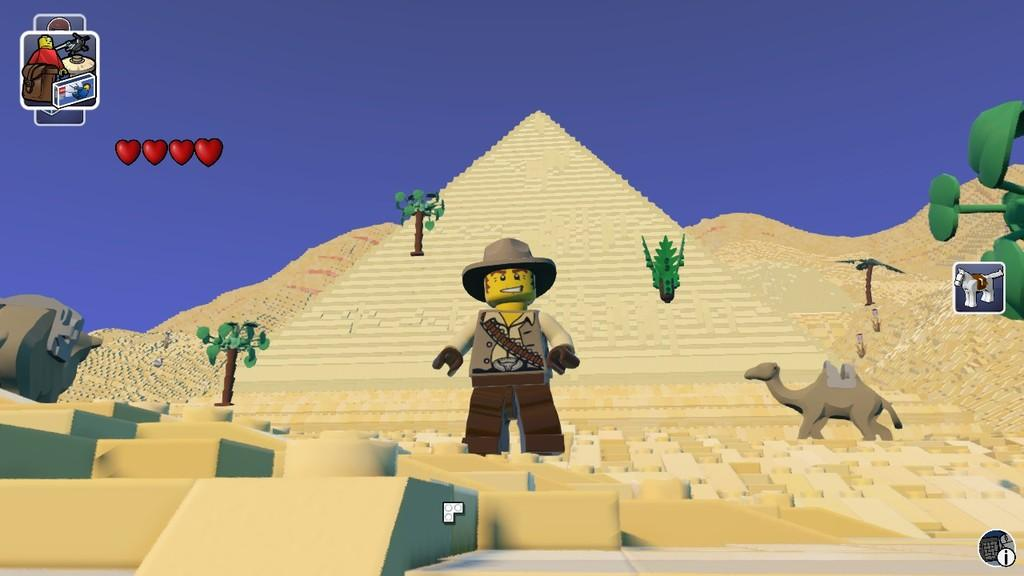What is the main subject in the image? There is a person in the image. What type of natural environment is visible in the image? There are trees in the image. What other living creature can be seen in the image? There is an animal in the image. What is visible above the trees and the person? The sky is visible in the image. How many baseballs can be seen in the hands of the person in the image? There is no mention of baseballs or hands in the image, so it cannot be determined if any baseballs are present or if the person is holding any. 